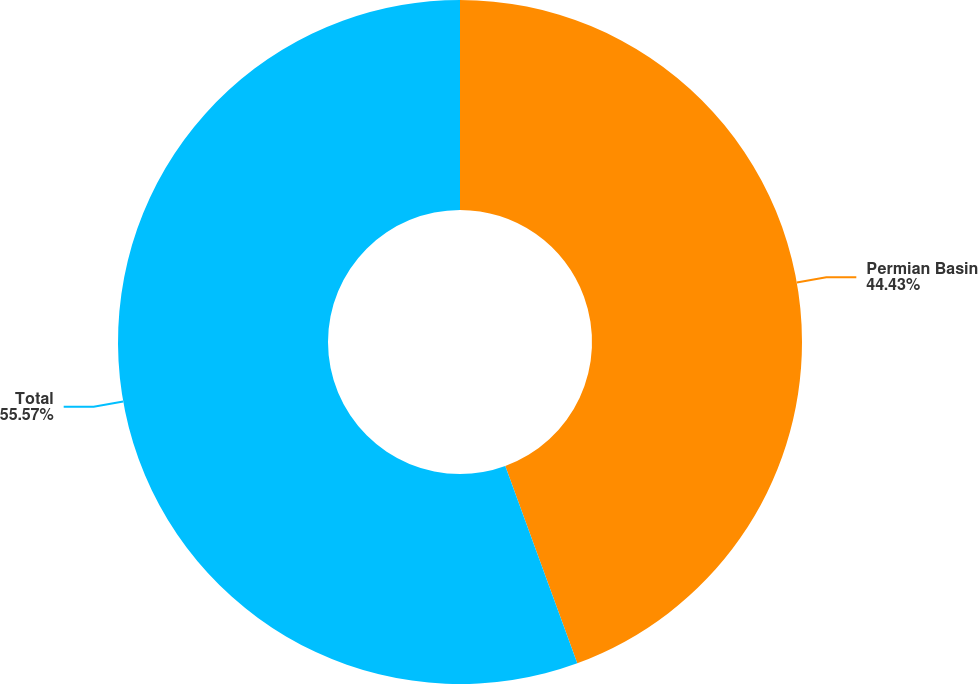Convert chart to OTSL. <chart><loc_0><loc_0><loc_500><loc_500><pie_chart><fcel>Permian Basin<fcel>Total<nl><fcel>44.43%<fcel>55.57%<nl></chart> 